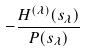Convert formula to latex. <formula><loc_0><loc_0><loc_500><loc_500>- \frac { H ^ { ( \lambda ) } ( s _ { \lambda } ) } { P ( s _ { \lambda } ) }</formula> 